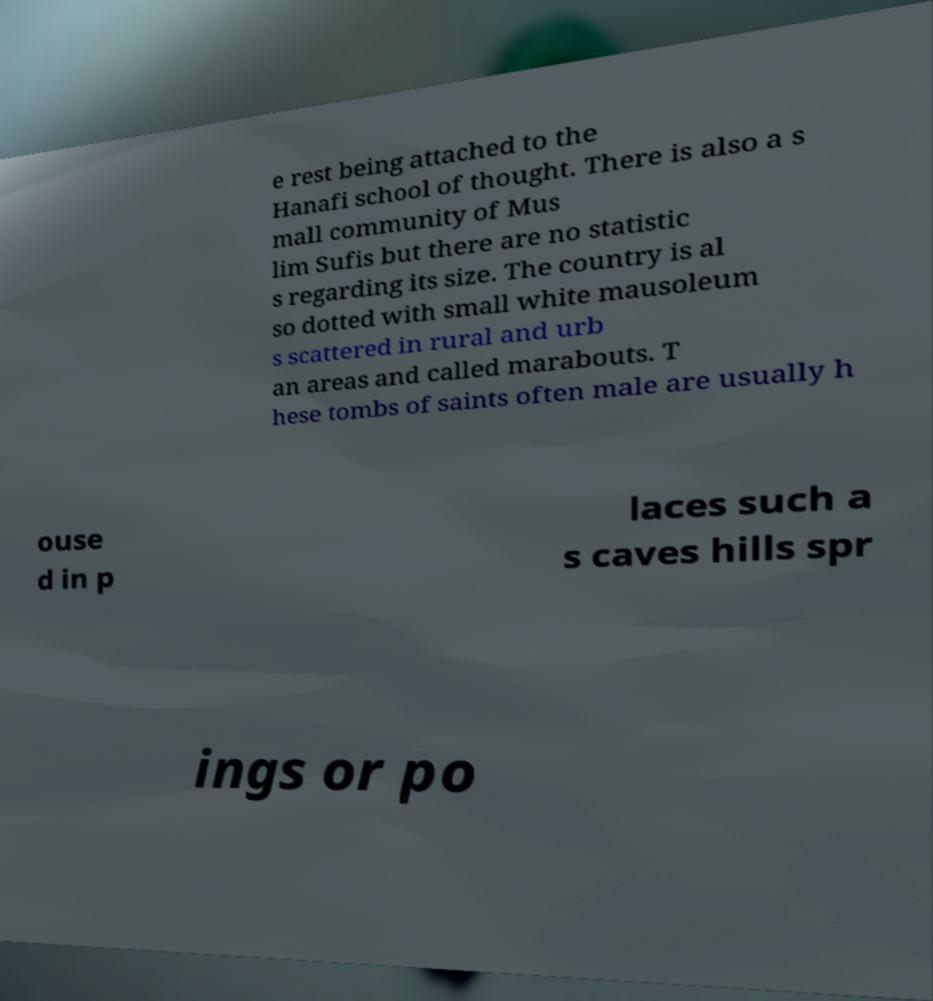Please identify and transcribe the text found in this image. e rest being attached to the Hanafi school of thought. There is also a s mall community of Mus lim Sufis but there are no statistic s regarding its size. The country is al so dotted with small white mausoleum s scattered in rural and urb an areas and called marabouts. T hese tombs of saints often male are usually h ouse d in p laces such a s caves hills spr ings or po 